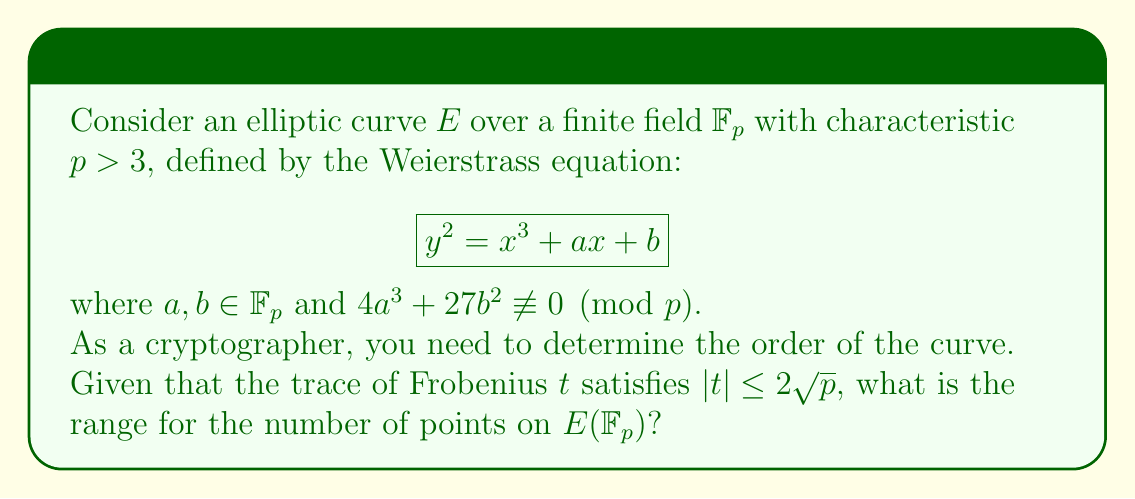Can you solve this math problem? To determine the range for the number of points on $E(\mathbb{F}_p)$, we'll follow these steps:

1) Recall Hasse's Theorem, which states that for an elliptic curve $E$ over $\mathbb{F}_p$, the number of points $\#E(\mathbb{F}_p)$ satisfies:

   $$|\#E(\mathbb{F}_p) - (p + 1)| \leq 2\sqrt{p}$$

2) The trace of Frobenius $t$ is defined as:

   $$t = p + 1 - \#E(\mathbb{F}_p)$$

3) Given that $|t| \leq 2\sqrt{p}$, we can rewrite this as:

   $$-2\sqrt{p} \leq t \leq 2\sqrt{p}$$

4) Substituting the definition of $t$:

   $$-2\sqrt{p} \leq p + 1 - \#E(\mathbb{F}_p) \leq 2\sqrt{p}$$

5) Rearranging the inequalities:

   $$p + 1 - 2\sqrt{p} \leq \#E(\mathbb{F}_p) \leq p + 1 + 2\sqrt{p}$$

6) Therefore, the range for the number of points on $E(\mathbb{F}_p)$ is:

   $$[p + 1 - 2\sqrt{p}, p + 1 + 2\sqrt{p}]$$

This interval is known as the Hasse interval and is crucial for understanding the group structure of elliptic curves used in cryptography.
Answer: $[p + 1 - 2\sqrt{p}, p + 1 + 2\sqrt{p}]$ 